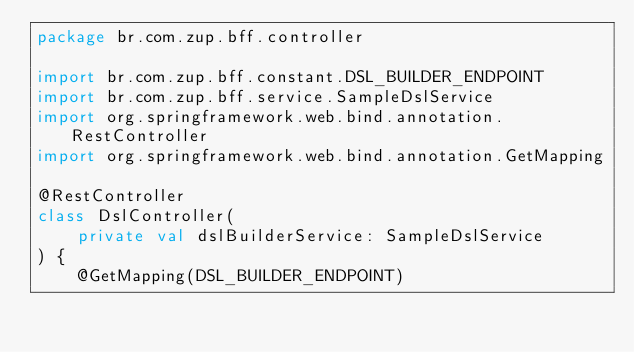<code> <loc_0><loc_0><loc_500><loc_500><_Kotlin_>package br.com.zup.bff.controller

import br.com.zup.bff.constant.DSL_BUILDER_ENDPOINT
import br.com.zup.bff.service.SampleDslService
import org.springframework.web.bind.annotation.RestController
import org.springframework.web.bind.annotation.GetMapping

@RestController
class DslController(
    private val dslBuilderService: SampleDslService
) {
    @GetMapping(DSL_BUILDER_ENDPOINT)</code> 